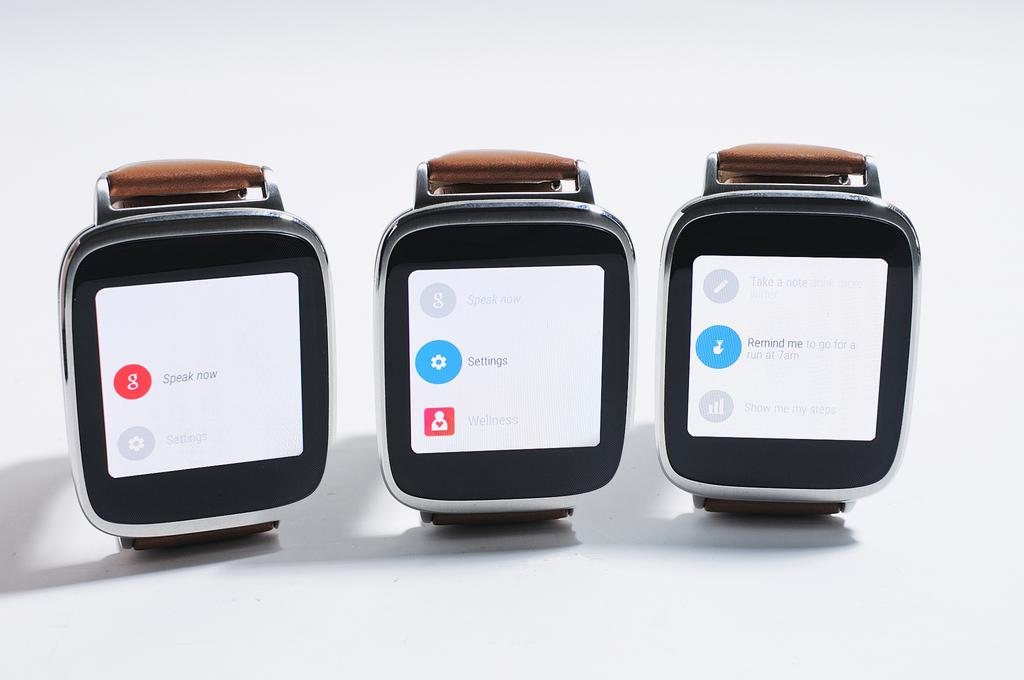What is the label on the red icon?
Provide a succinct answer. Speak now. 